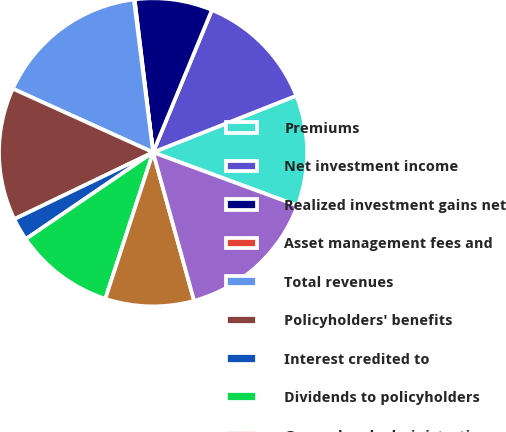<chart> <loc_0><loc_0><loc_500><loc_500><pie_chart><fcel>Premiums<fcel>Net investment income<fcel>Realized investment gains net<fcel>Asset management fees and<fcel>Total revenues<fcel>Policyholders' benefits<fcel>Interest credited to<fcel>Dividends to policyholders<fcel>General and administrative<fcel>Total benefits and expenses<nl><fcel>11.62%<fcel>12.77%<fcel>8.15%<fcel>0.08%<fcel>16.23%<fcel>13.92%<fcel>2.38%<fcel>10.46%<fcel>9.31%<fcel>15.08%<nl></chart> 